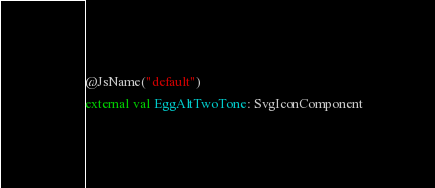<code> <loc_0><loc_0><loc_500><loc_500><_Kotlin_>
@JsName("default")
external val EggAltTwoTone: SvgIconComponent
</code> 